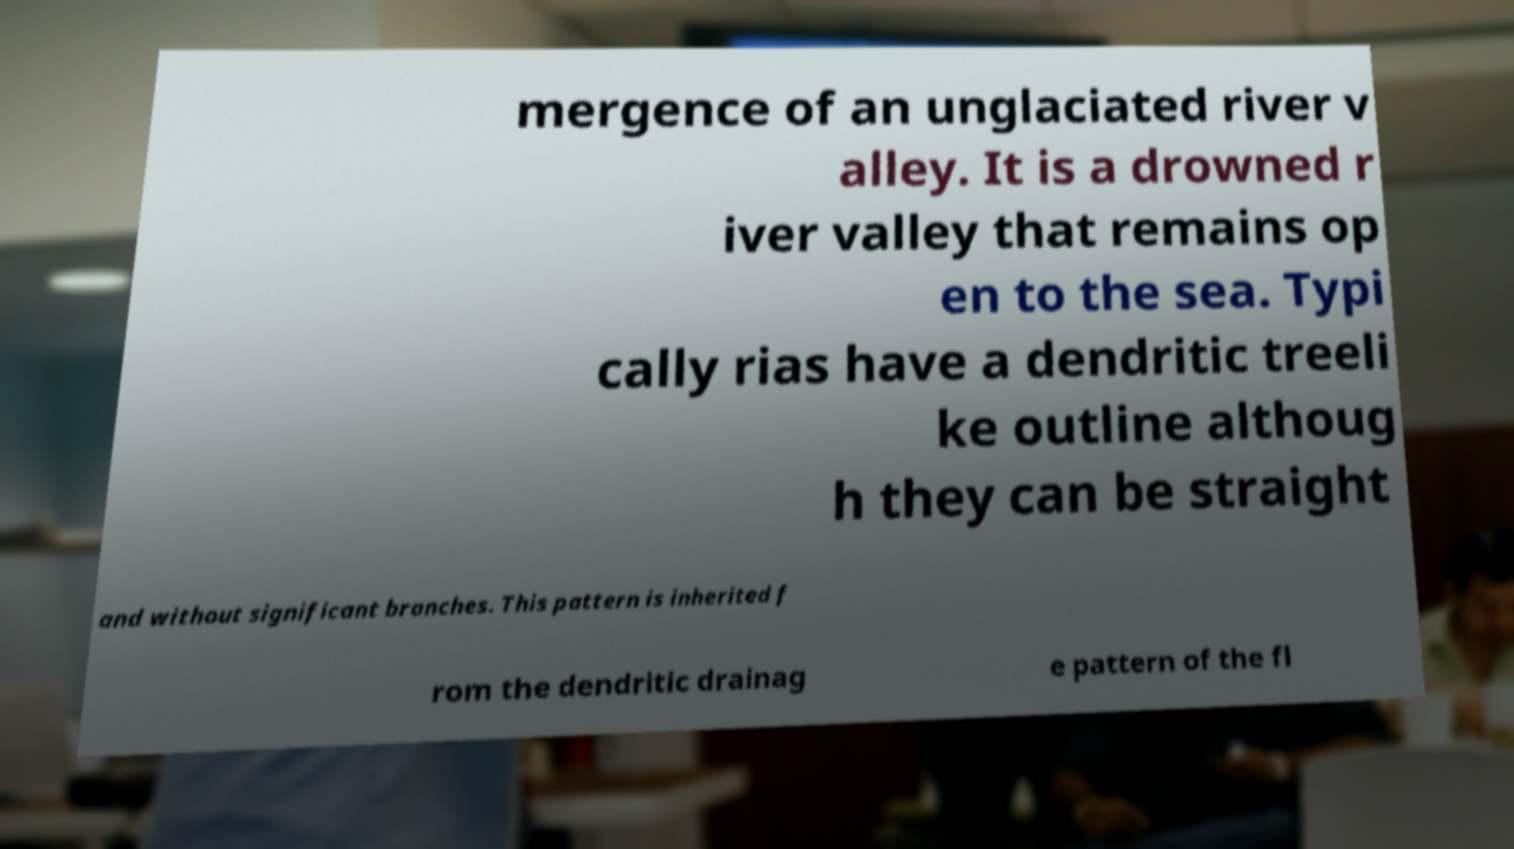What messages or text are displayed in this image? I need them in a readable, typed format. mergence of an unglaciated river v alley. It is a drowned r iver valley that remains op en to the sea. Typi cally rias have a dendritic treeli ke outline althoug h they can be straight and without significant branches. This pattern is inherited f rom the dendritic drainag e pattern of the fl 